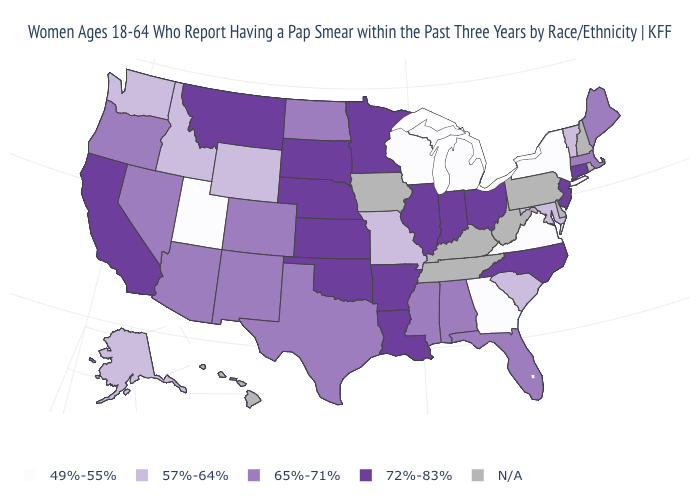Name the states that have a value in the range N/A?
Concise answer only. Delaware, Hawaii, Iowa, Kentucky, New Hampshire, Pennsylvania, Rhode Island, Tennessee, West Virginia. What is the value of New Mexico?
Concise answer only. 65%-71%. What is the value of Nebraska?
Be succinct. 72%-83%. What is the highest value in the USA?
Keep it brief. 72%-83%. What is the value of Maryland?
Concise answer only. 57%-64%. What is the lowest value in the USA?
Concise answer only. 49%-55%. What is the value of Nevada?
Concise answer only. 65%-71%. What is the value of Idaho?
Concise answer only. 57%-64%. Name the states that have a value in the range 57%-64%?
Answer briefly. Alaska, Idaho, Maryland, Missouri, South Carolina, Vermont, Washington, Wyoming. Name the states that have a value in the range 65%-71%?
Quick response, please. Alabama, Arizona, Colorado, Florida, Maine, Massachusetts, Mississippi, Nevada, New Mexico, North Dakota, Oregon, Texas. Name the states that have a value in the range N/A?
Quick response, please. Delaware, Hawaii, Iowa, Kentucky, New Hampshire, Pennsylvania, Rhode Island, Tennessee, West Virginia. What is the highest value in states that border Kentucky?
Write a very short answer. 72%-83%. What is the value of South Dakota?
Write a very short answer. 72%-83%. What is the value of Indiana?
Short answer required. 72%-83%. 